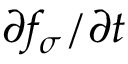Convert formula to latex. <formula><loc_0><loc_0><loc_500><loc_500>\partial f _ { \sigma } / \partial t</formula> 